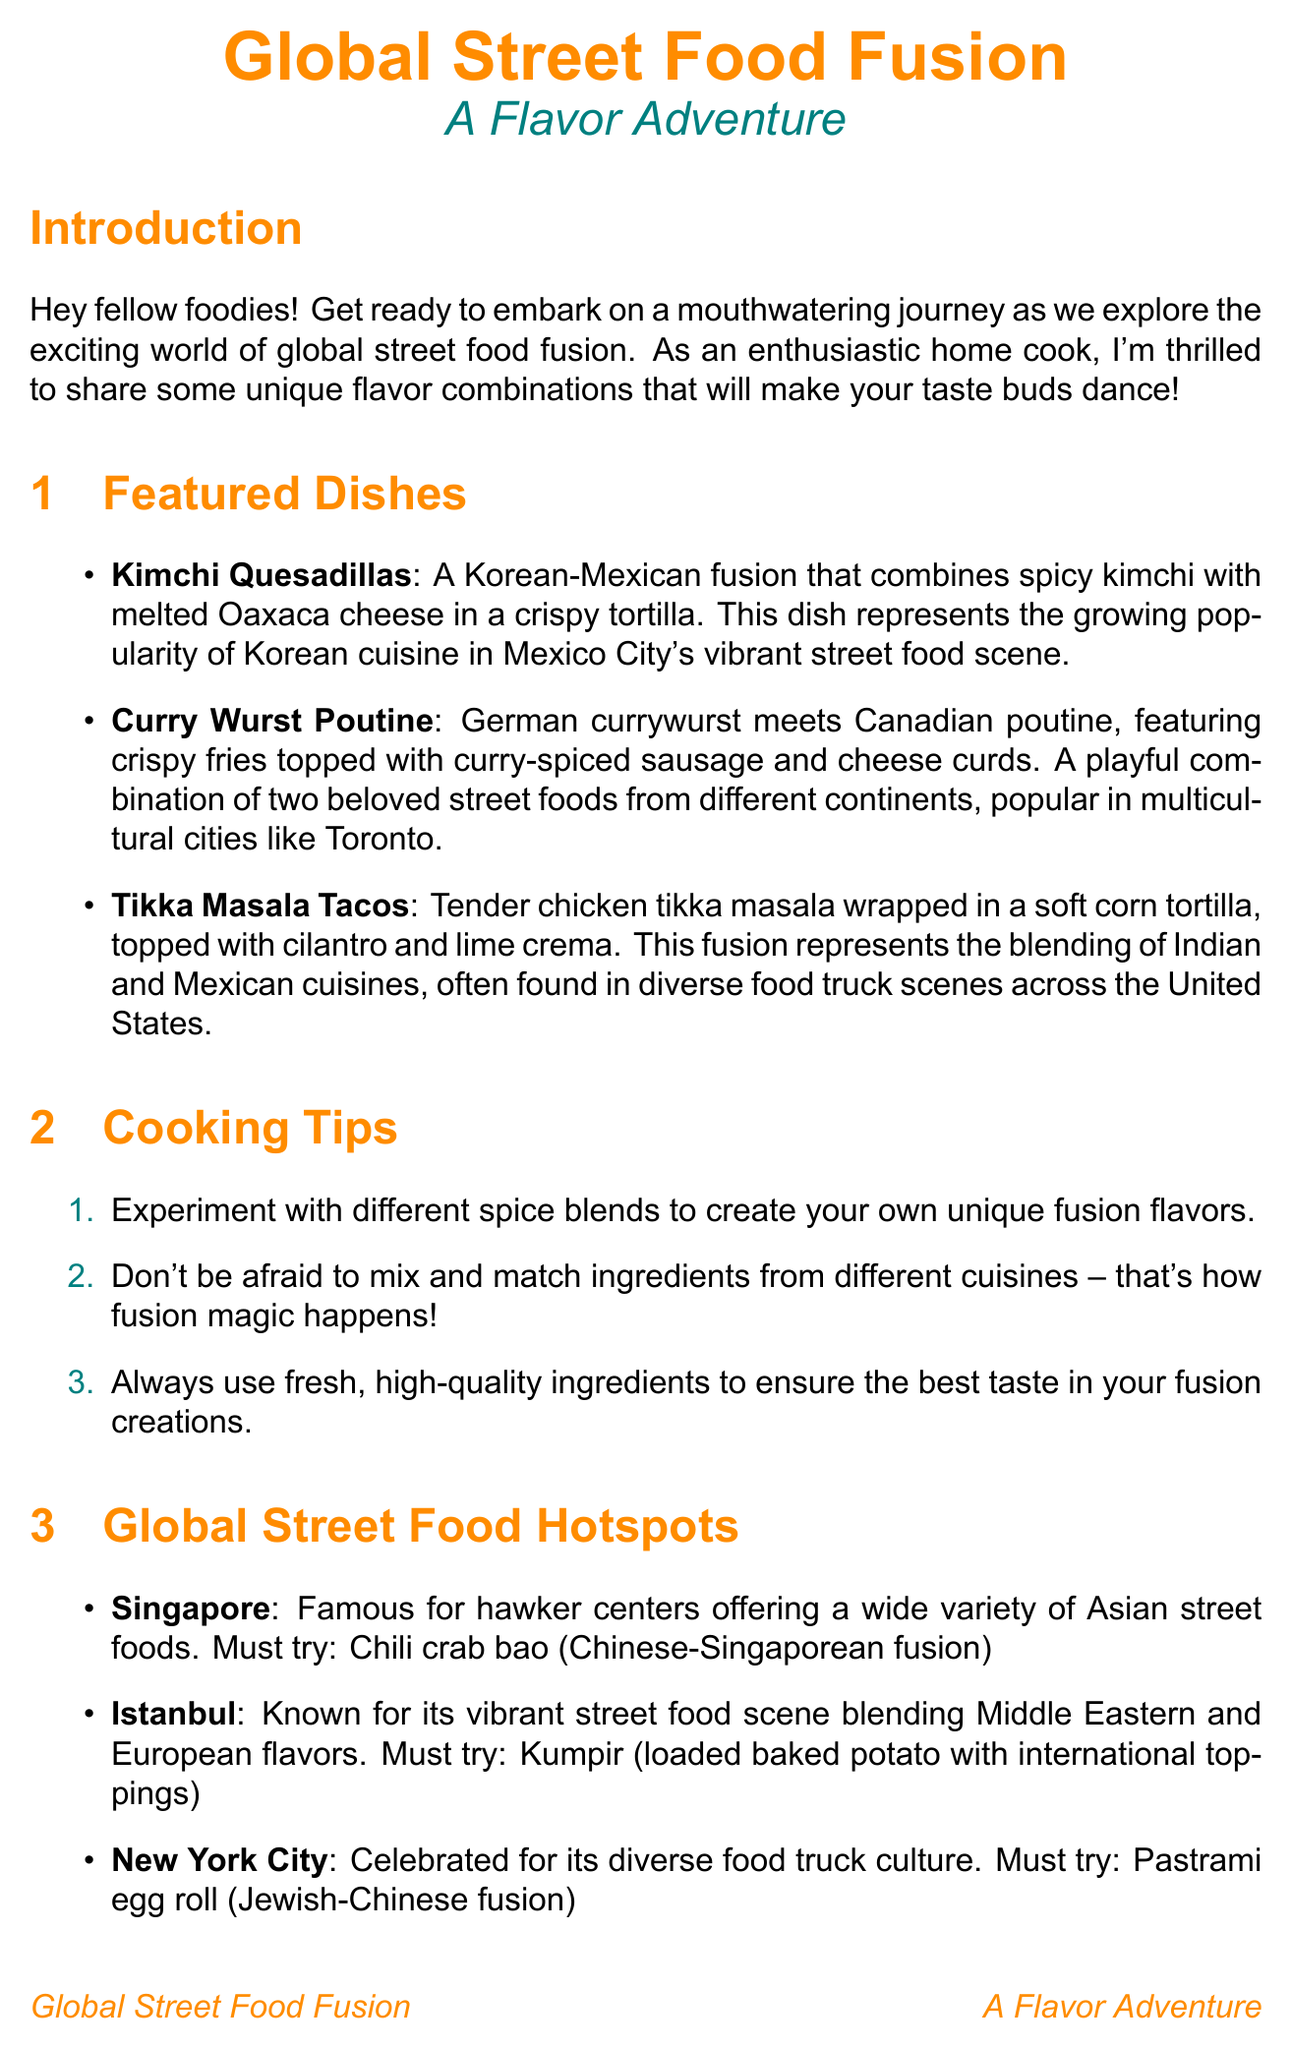What is the title of the newsletter? The title of the newsletter is indicated at the beginning of the document.
Answer: Global Street Food Fusion: A Flavor Adventure What dish combines kimchi and Oaxaca cheese? This dish is specifically mentioned in the featured dishes section.
Answer: Kimchi Quesadillas Which city is famous for chili crab bao? The city associated with this dish is part of the global street food hotspots section.
Answer: Singapore What type of cuisine is Tikka Masala Tacos a fusion of? The cultural insight describes the blending of two cuisines.
Answer: Indian and Mexican How many cooking tips are provided in the newsletter? The exact number of cooking tips can be counted from the list.
Answer: Three What dish is spotlighted in the recipe section? This can be found in the recipe spotlight subsection.
Answer: Tandoori Chicken Nachos What are the two ingredients mentioned for Curry Wurst Poutine? The ingredients can be retrieved from the dish description.
Answer: Fries and curry-spiced sausage Which city is known for the pastrami egg roll? This information is part of the global street food hotspots.
Answer: New York City 